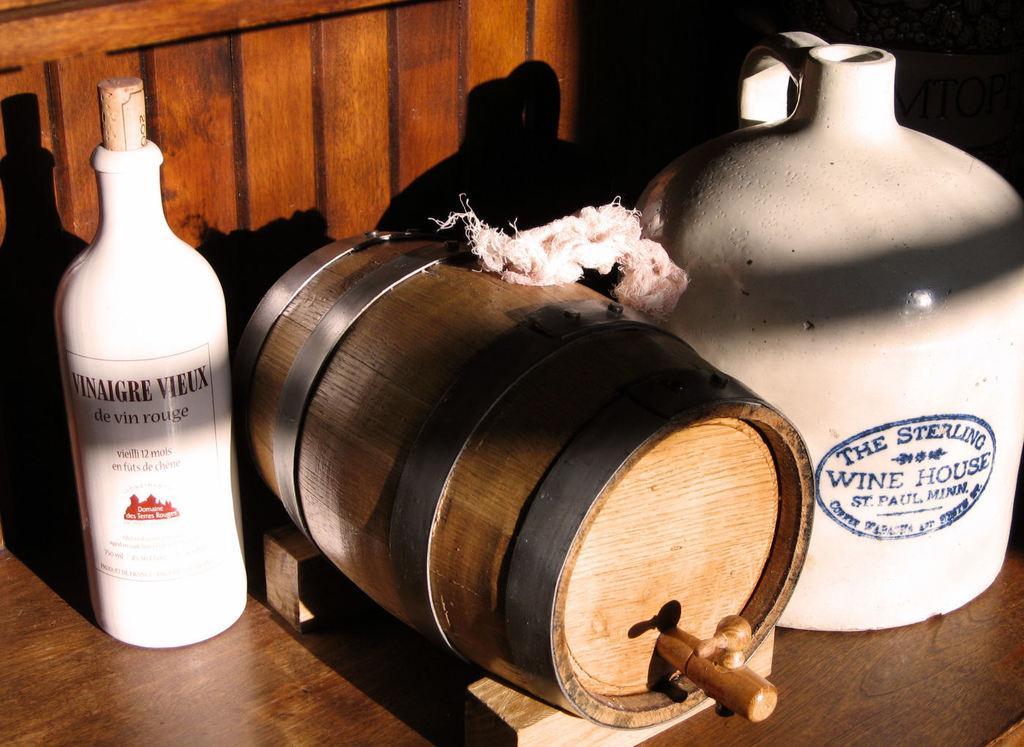How would you summarize this image in a sentence or two? In this picture we can see bottle, barrel, cloth and jar on the wooden platform. 